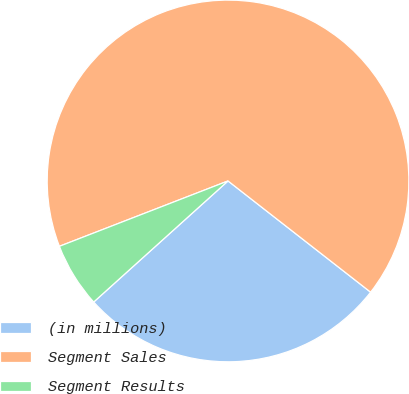<chart> <loc_0><loc_0><loc_500><loc_500><pie_chart><fcel>(in millions)<fcel>Segment Sales<fcel>Segment Results<nl><fcel>27.78%<fcel>66.43%<fcel>5.79%<nl></chart> 